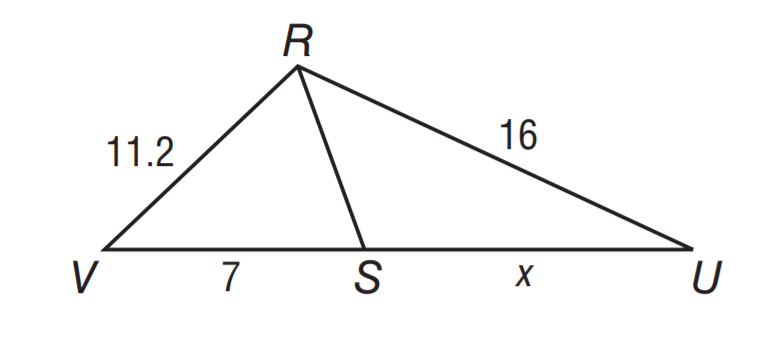Answer the mathemtical geometry problem and directly provide the correct option letter.
Question: R S bisects \angle V R U. Solve for x.
Choices: A: 5.6 B: 7 C: 8 D: 10 D 